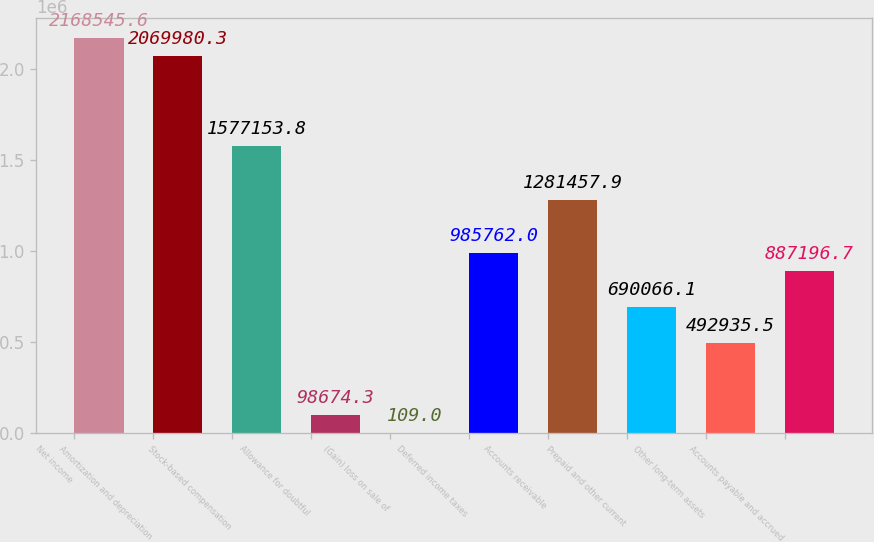Convert chart. <chart><loc_0><loc_0><loc_500><loc_500><bar_chart><fcel>Net income<fcel>Amortization and depreciation<fcel>Stock-based compensation<fcel>Allowance for doubtful<fcel>(Gain) loss on sale of<fcel>Deferred income taxes<fcel>Accounts receivable<fcel>Prepaid and other current<fcel>Other long-term assets<fcel>Accounts payable and accrued<nl><fcel>2.16855e+06<fcel>2.06998e+06<fcel>1.57715e+06<fcel>98674.3<fcel>109<fcel>985762<fcel>1.28146e+06<fcel>690066<fcel>492936<fcel>887197<nl></chart> 